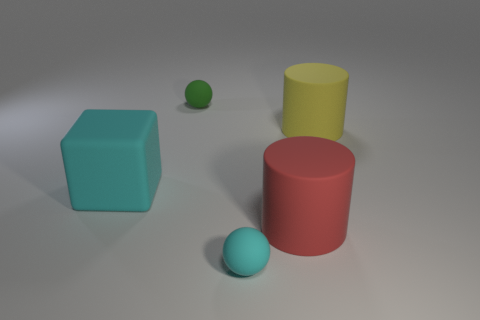What could be the purpose of this arrangement of shapes? This arrangement appears to be an exercise in 3D modeling or a demonstration of basic geometric shapes and colors for educational purposes. It showcases various shapes and colors interacting with light and shadow, which may help in the understanding of spatial relationships and visual aesthetics. 